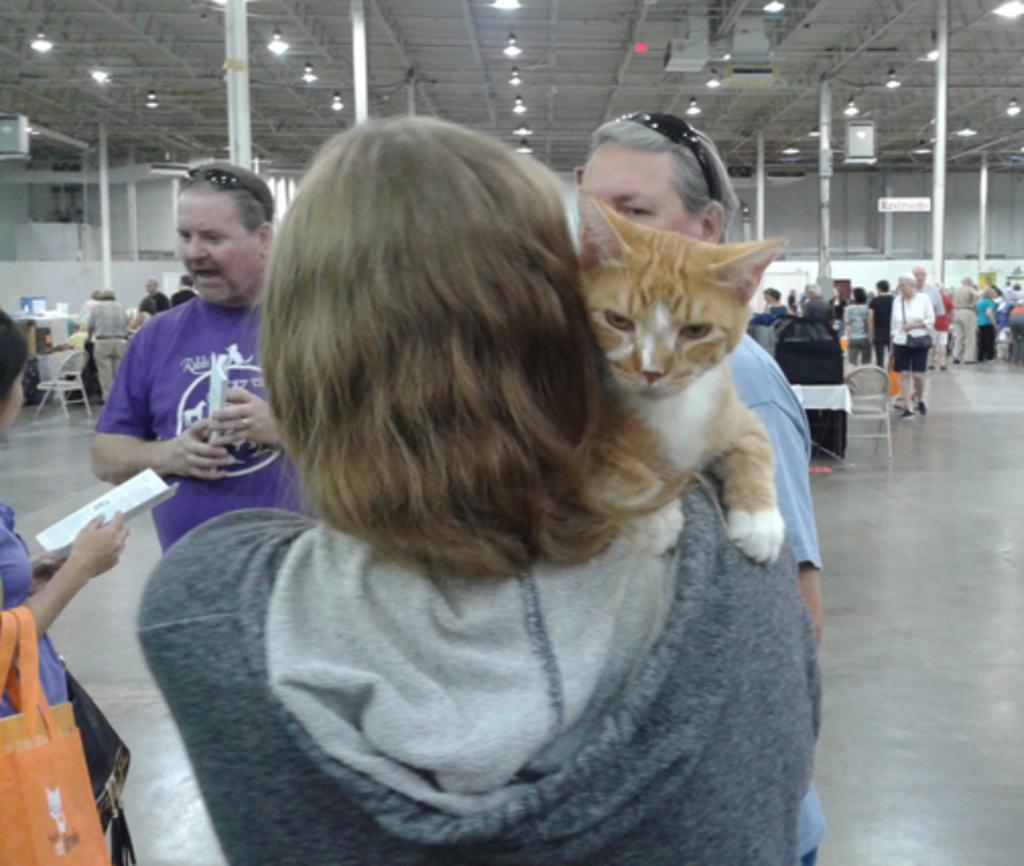How would you summarize this image in a sentence or two? This picture looks like it is clicked inside in a hall. There are many people in this image. In the front there are four people standing. In the middle, the woman is holding a brown cat. To the left, the woman is wearing a blue shirt and a bag in her hand. In the background there is a roof, to which many lights are fixed. 